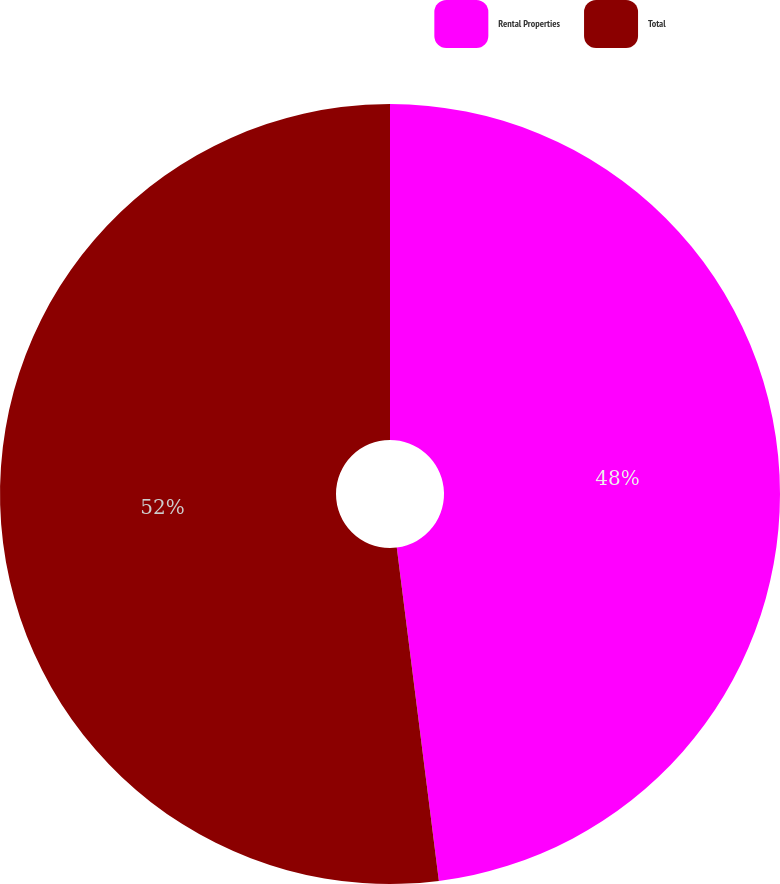<chart> <loc_0><loc_0><loc_500><loc_500><pie_chart><fcel>Rental Properties<fcel>Total<nl><fcel>48.0%<fcel>52.0%<nl></chart> 